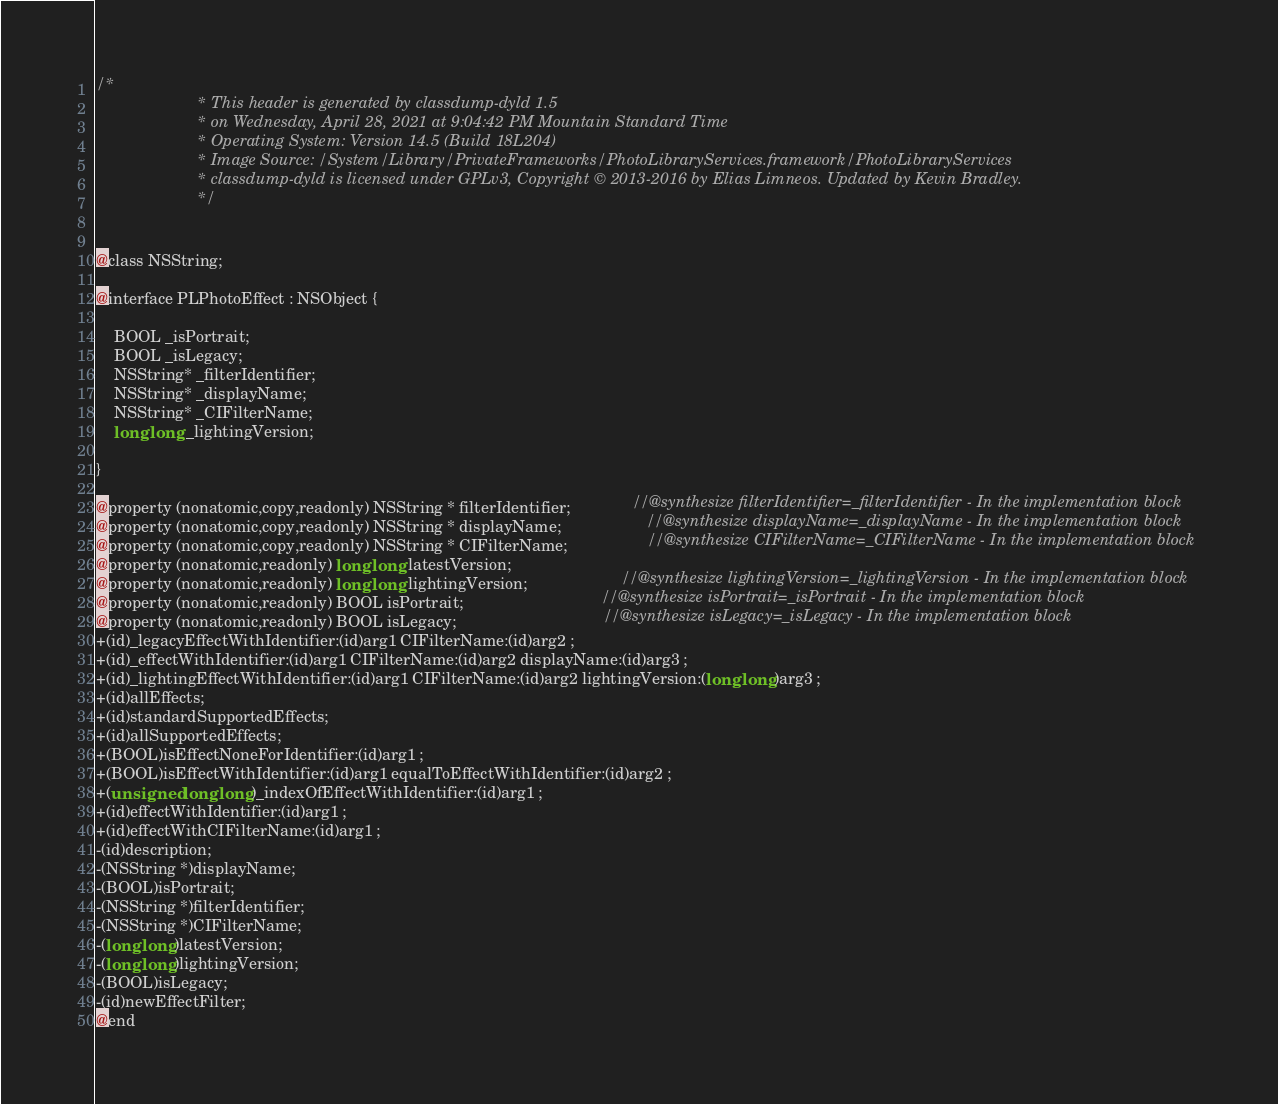<code> <loc_0><loc_0><loc_500><loc_500><_C_>/*
                       * This header is generated by classdump-dyld 1.5
                       * on Wednesday, April 28, 2021 at 9:04:42 PM Mountain Standard Time
                       * Operating System: Version 14.5 (Build 18L204)
                       * Image Source: /System/Library/PrivateFrameworks/PhotoLibraryServices.framework/PhotoLibraryServices
                       * classdump-dyld is licensed under GPLv3, Copyright © 2013-2016 by Elias Limneos. Updated by Kevin Bradley.
                       */


@class NSString;

@interface PLPhotoEffect : NSObject {

	BOOL _isPortrait;
	BOOL _isLegacy;
	NSString* _filterIdentifier;
	NSString* _displayName;
	NSString* _CIFilterName;
	long long _lightingVersion;

}

@property (nonatomic,copy,readonly) NSString * filterIdentifier;              //@synthesize filterIdentifier=_filterIdentifier - In the implementation block
@property (nonatomic,copy,readonly) NSString * displayName;                   //@synthesize displayName=_displayName - In the implementation block
@property (nonatomic,copy,readonly) NSString * CIFilterName;                  //@synthesize CIFilterName=_CIFilterName - In the implementation block
@property (nonatomic,readonly) long long latestVersion; 
@property (nonatomic,readonly) long long lightingVersion;                     //@synthesize lightingVersion=_lightingVersion - In the implementation block
@property (nonatomic,readonly) BOOL isPortrait;                               //@synthesize isPortrait=_isPortrait - In the implementation block
@property (nonatomic,readonly) BOOL isLegacy;                                 //@synthesize isLegacy=_isLegacy - In the implementation block
+(id)_legacyEffectWithIdentifier:(id)arg1 CIFilterName:(id)arg2 ;
+(id)_effectWithIdentifier:(id)arg1 CIFilterName:(id)arg2 displayName:(id)arg3 ;
+(id)_lightingEffectWithIdentifier:(id)arg1 CIFilterName:(id)arg2 lightingVersion:(long long)arg3 ;
+(id)allEffects;
+(id)standardSupportedEffects;
+(id)allSupportedEffects;
+(BOOL)isEffectNoneForIdentifier:(id)arg1 ;
+(BOOL)isEffectWithIdentifier:(id)arg1 equalToEffectWithIdentifier:(id)arg2 ;
+(unsigned long long)_indexOfEffectWithIdentifier:(id)arg1 ;
+(id)effectWithIdentifier:(id)arg1 ;
+(id)effectWithCIFilterName:(id)arg1 ;
-(id)description;
-(NSString *)displayName;
-(BOOL)isPortrait;
-(NSString *)filterIdentifier;
-(NSString *)CIFilterName;
-(long long)latestVersion;
-(long long)lightingVersion;
-(BOOL)isLegacy;
-(id)newEffectFilter;
@end

</code> 